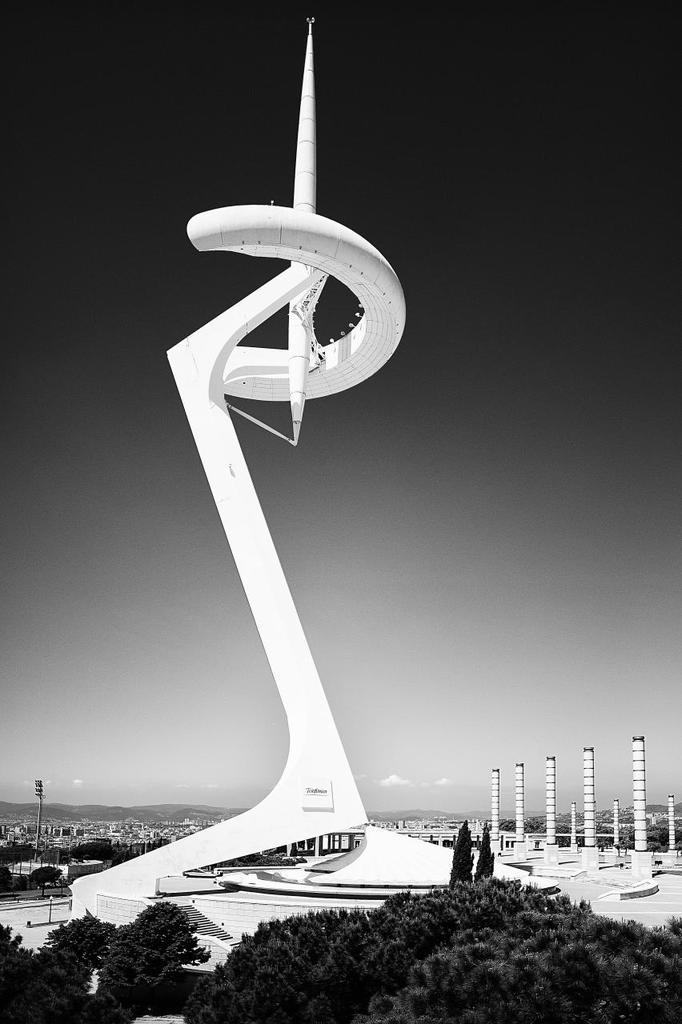What type of building is featured in the image? There is an architecture building in the image. What other elements can be seen in the image besides the building? There are trees in the image. What is the color scheme of the image? The image is black and white in color. Are there any animals from the zoo present in the image? There is no mention of a zoo or any animals in the image; it features an architecture building and trees. Can you identify any servants or staff members in the image? There is no indication of servants or staff members in the image. What type of musical instrument can be seen in the image? There is no musical instrument present in the image. 